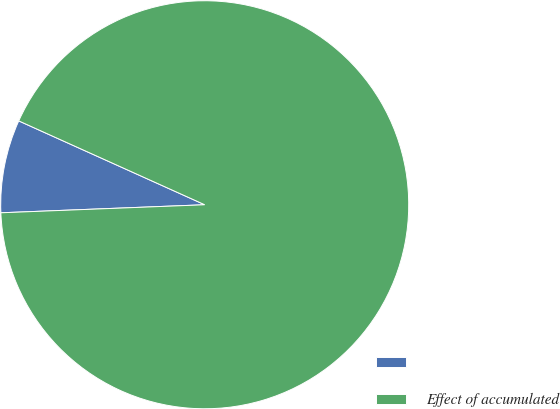Convert chart. <chart><loc_0><loc_0><loc_500><loc_500><pie_chart><ecel><fcel>Effect of accumulated<nl><fcel>7.37%<fcel>92.63%<nl></chart> 